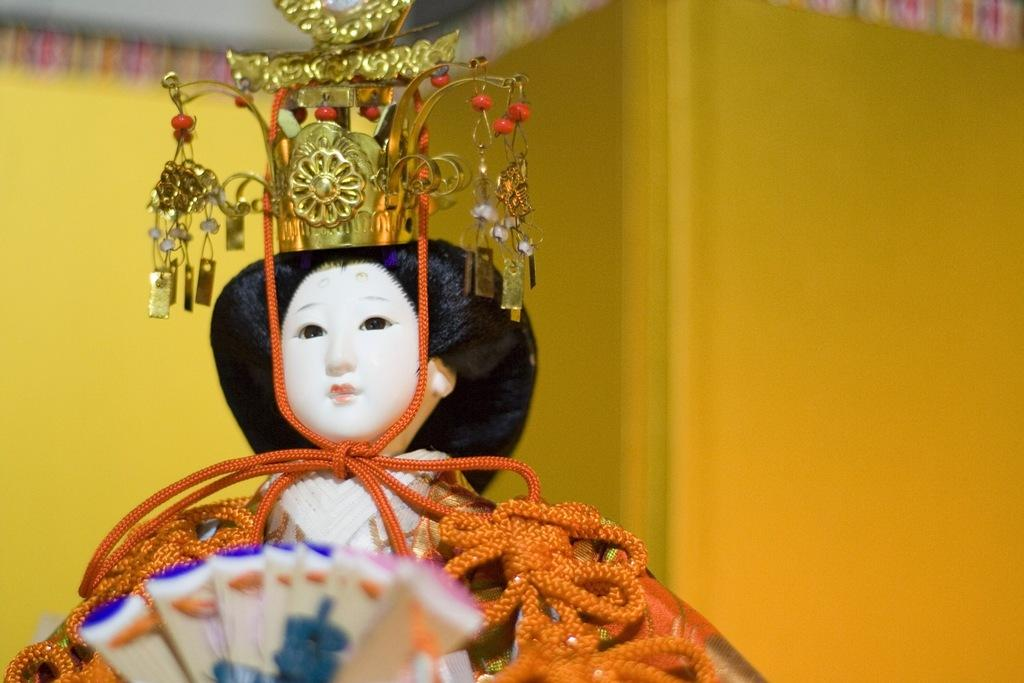What is the main subject of the image? There is a doll in the image. Does the doll have any additional items with it? Yes, the doll has accessories. What can be seen behind the doll in the image? There is a wall behind the doll. Where is the cactus located in the image? There is no cactus present in the image. What type of alarm is going off in the image? There is no alarm present in the image. 